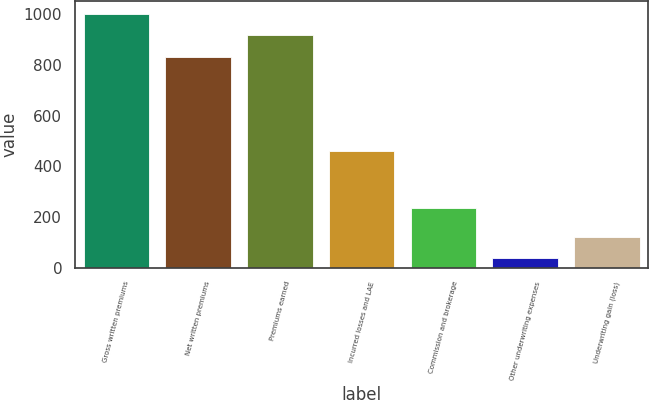<chart> <loc_0><loc_0><loc_500><loc_500><bar_chart><fcel>Gross written premiums<fcel>Net written premiums<fcel>Premiums earned<fcel>Incurred losses and LAE<fcel>Commission and brokerage<fcel>Other underwriting expenses<fcel>Underwriting gain (loss)<nl><fcel>1002.72<fcel>831.9<fcel>917.31<fcel>461.9<fcel>234<fcel>36.3<fcel>121.71<nl></chart> 